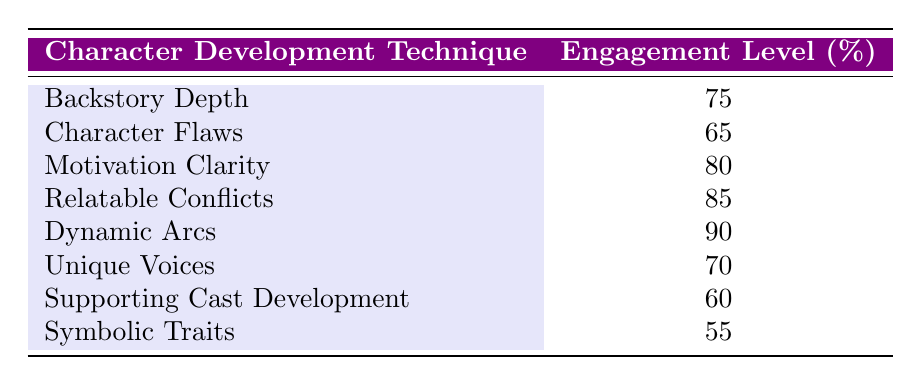What is the engagement level for Dynamic Arcs? The table shows the engagement level for each character development technique. Looking at the row for "Dynamic Arcs," the engagement level is indicated as 90.
Answer: 90 Which character development technique has the lowest engagement level? By scanning through the engagement levels in the table, "Symbolic Traits" has the lowest value at 55.
Answer: Symbolic Traits What is the average engagement level of Backstory Depth, Character Flaws, and Unique Voices? We first take the engagement levels of the three techniques: Backstory Depth (75), Character Flaws (65), and Unique Voices (70). The sum is 75 + 65 + 70 = 210. There are 3 techniques, so we calculate the average as 210/3 = 70.
Answer: 70 Is the engagement level for Motivation Clarity greater than that for Character Flaws? The engagement level for Motivation Clarity is 80, while for Character Flaws it is 65. Since 80 is greater than 65, the statement is true.
Answer: Yes Which technique has the highest engagement level and what is its value? Reviewing the engagement levels from the table, "Dynamic Arcs" has the highest engagement level of 90.
Answer: Dynamic Arcs, 90 What is the difference in engagement levels between Relatable Conflicts and Supporting Cast Development? The engagement level for Relatable Conflicts is 85, and for Supporting Cast Development, it is 60. Taking the difference gives us 85 - 60 = 25.
Answer: 25 Do Character Flaws and Unique Voices have higher engagement levels than Backstory Depth? The engagement level for Character Flaws is 65 and for Unique Voices is 70, which are both lower than Backstory Depth's level of 75. Therefore, the statement is false.
Answer: No If you combine the engagement levels of all techniques, what is the total? Adding all the engagement levels: 75 + 65 + 80 + 85 + 90 + 70 + 60 + 55 = 675.
Answer: 675 